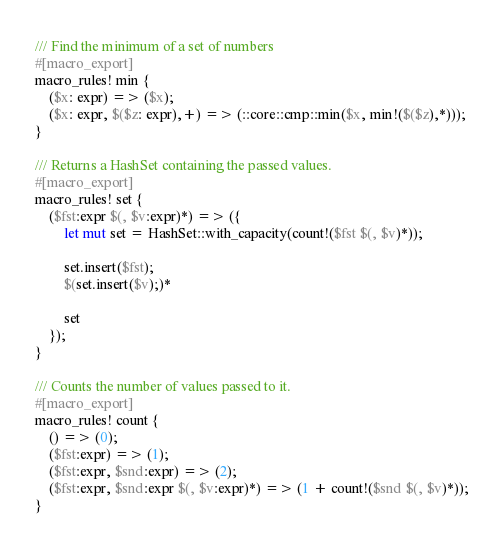<code> <loc_0><loc_0><loc_500><loc_500><_Rust_>/// Find the minimum of a set of numbers
#[macro_export]
macro_rules! min {
    ($x: expr) => ($x);
    ($x: expr, $($z: expr),+) => (::core::cmp::min($x, min!($($z),*)));
}

/// Returns a HashSet containing the passed values.
#[macro_export]
macro_rules! set {
    ($fst:expr $(, $v:expr)*) => ({
        let mut set = HashSet::with_capacity(count!($fst $(, $v)*));

        set.insert($fst);
        $(set.insert($v);)*

        set
    });
}

/// Counts the number of values passed to it.
#[macro_export]
macro_rules! count {
    () => (0);
    ($fst:expr) => (1);
    ($fst:expr, $snd:expr) => (2);
    ($fst:expr, $snd:expr $(, $v:expr)*) => (1 + count!($snd $(, $v)*));
}
</code> 